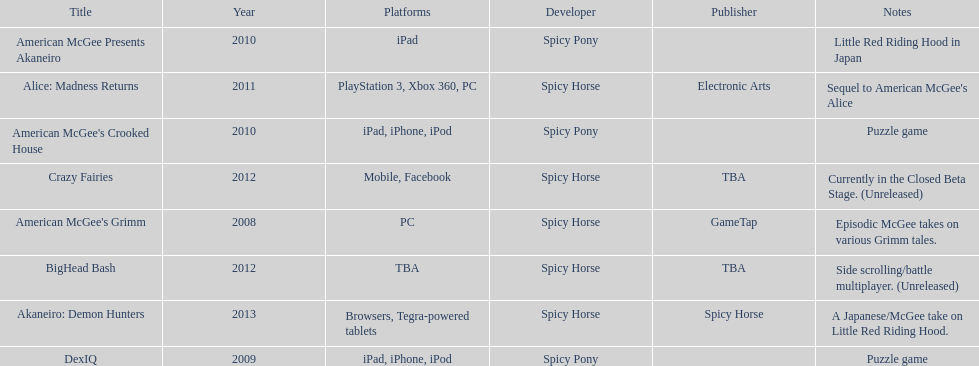What was the last game created by spicy horse Akaneiro: Demon Hunters. 